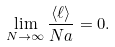<formula> <loc_0><loc_0><loc_500><loc_500>\lim _ { N \to \infty } \frac { \langle \ell \rangle } { N a } = 0 .</formula> 